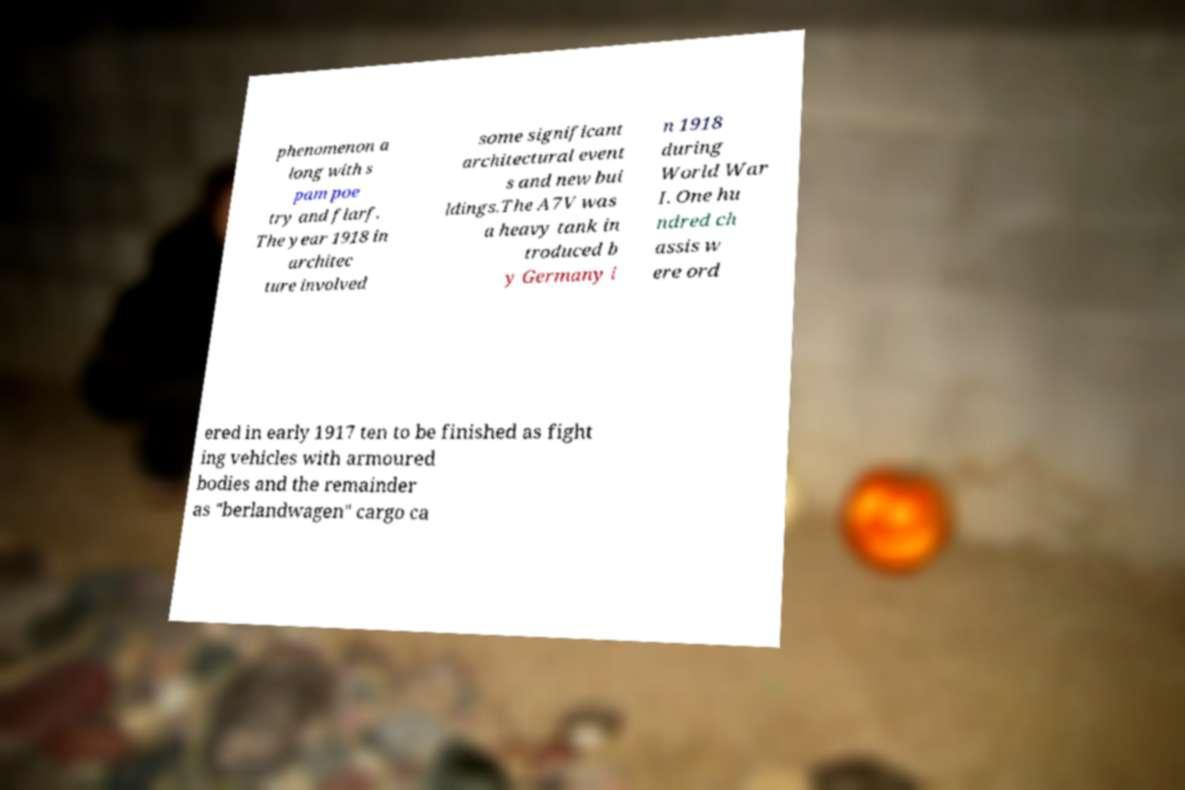I need the written content from this picture converted into text. Can you do that? phenomenon a long with s pam poe try and flarf. The year 1918 in architec ture involved some significant architectural event s and new bui ldings.The A7V was a heavy tank in troduced b y Germany i n 1918 during World War I. One hu ndred ch assis w ere ord ered in early 1917 ten to be finished as fight ing vehicles with armoured bodies and the remainder as "berlandwagen" cargo ca 